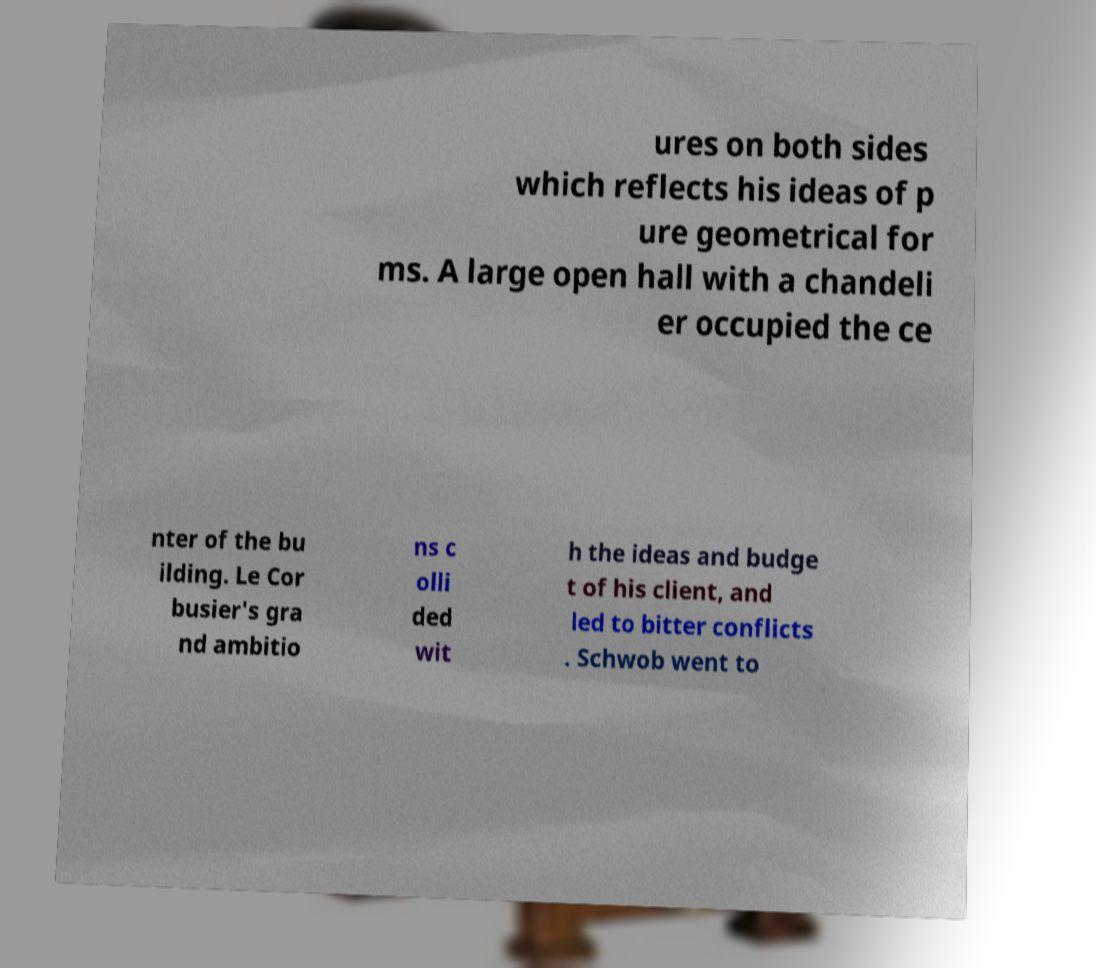Can you accurately transcribe the text from the provided image for me? ures on both sides which reflects his ideas of p ure geometrical for ms. A large open hall with a chandeli er occupied the ce nter of the bu ilding. Le Cor busier's gra nd ambitio ns c olli ded wit h the ideas and budge t of his client, and led to bitter conflicts . Schwob went to 